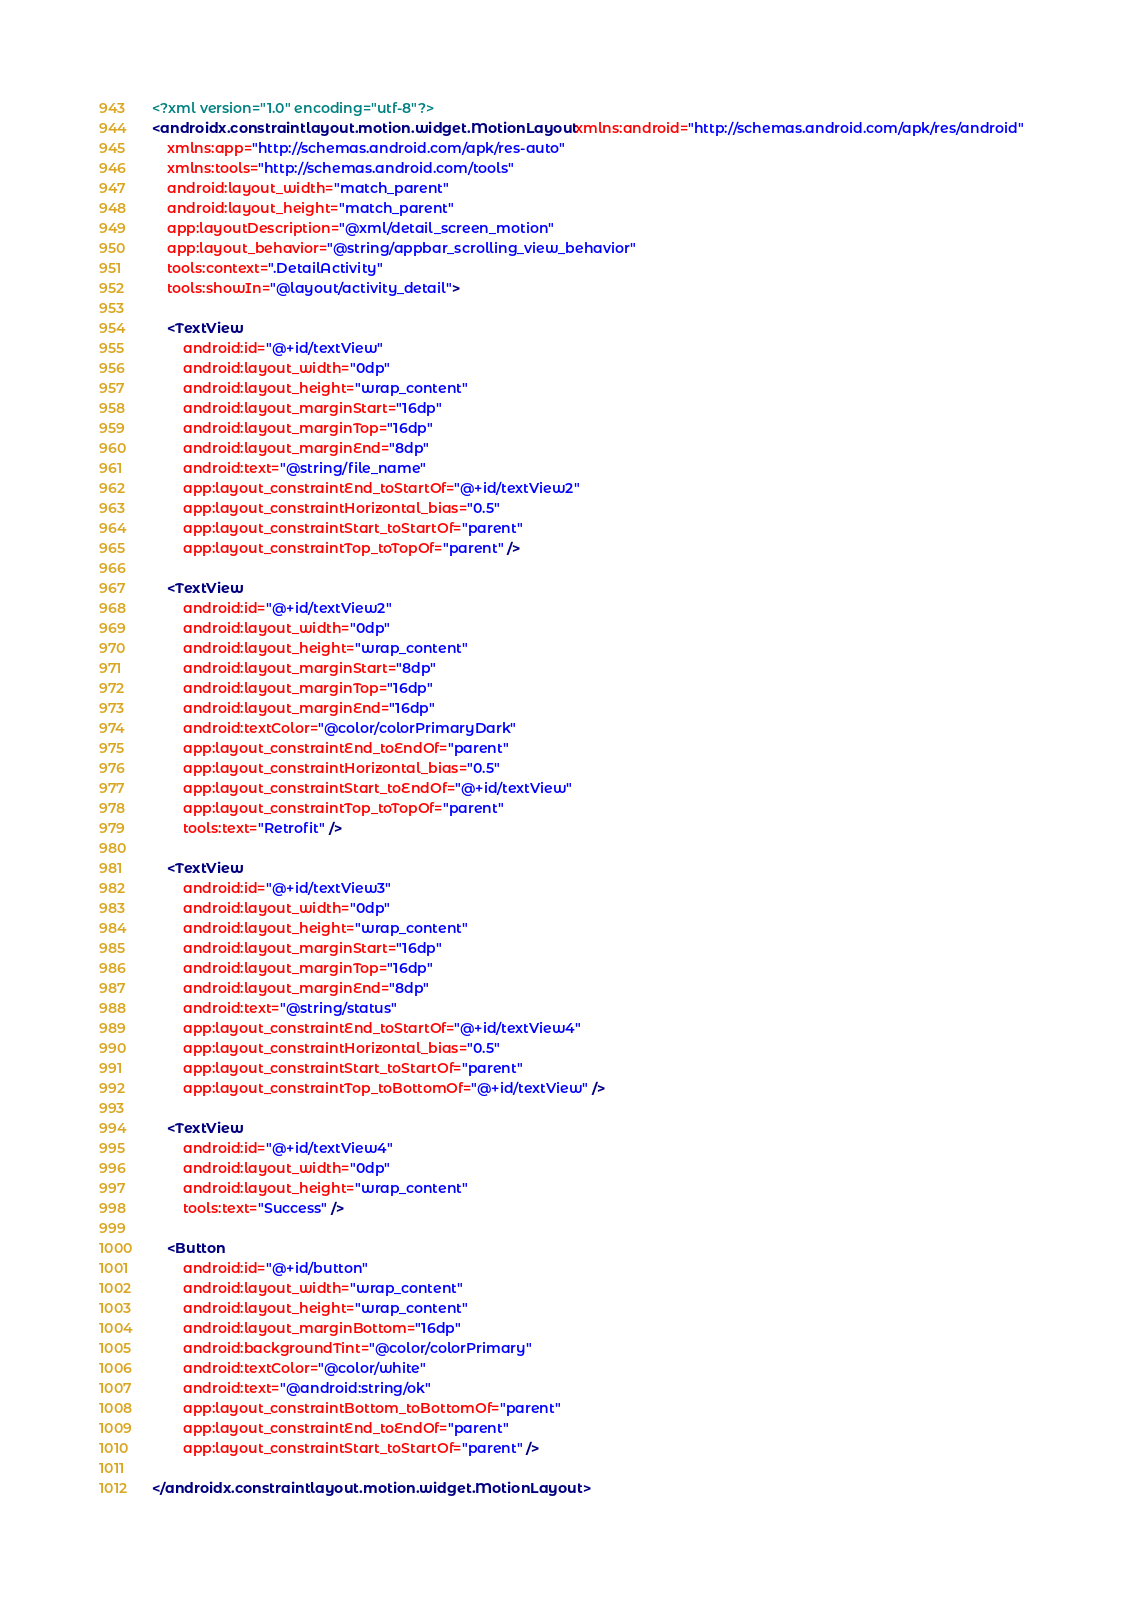<code> <loc_0><loc_0><loc_500><loc_500><_XML_><?xml version="1.0" encoding="utf-8"?>
<androidx.constraintlayout.motion.widget.MotionLayout xmlns:android="http://schemas.android.com/apk/res/android"
    xmlns:app="http://schemas.android.com/apk/res-auto"
    xmlns:tools="http://schemas.android.com/tools"
    android:layout_width="match_parent"
    android:layout_height="match_parent"
    app:layoutDescription="@xml/detail_screen_motion"
    app:layout_behavior="@string/appbar_scrolling_view_behavior"
    tools:context=".DetailActivity"
    tools:showIn="@layout/activity_detail">

    <TextView
        android:id="@+id/textView"
        android:layout_width="0dp"
        android:layout_height="wrap_content"
        android:layout_marginStart="16dp"
        android:layout_marginTop="16dp"
        android:layout_marginEnd="8dp"
        android:text="@string/file_name"
        app:layout_constraintEnd_toStartOf="@+id/textView2"
        app:layout_constraintHorizontal_bias="0.5"
        app:layout_constraintStart_toStartOf="parent"
        app:layout_constraintTop_toTopOf="parent" />

    <TextView
        android:id="@+id/textView2"
        android:layout_width="0dp"
        android:layout_height="wrap_content"
        android:layout_marginStart="8dp"
        android:layout_marginTop="16dp"
        android:layout_marginEnd="16dp"
        android:textColor="@color/colorPrimaryDark"
        app:layout_constraintEnd_toEndOf="parent"
        app:layout_constraintHorizontal_bias="0.5"
        app:layout_constraintStart_toEndOf="@+id/textView"
        app:layout_constraintTop_toTopOf="parent"
        tools:text="Retrofit" />

    <TextView
        android:id="@+id/textView3"
        android:layout_width="0dp"
        android:layout_height="wrap_content"
        android:layout_marginStart="16dp"
        android:layout_marginTop="16dp"
        android:layout_marginEnd="8dp"
        android:text="@string/status"
        app:layout_constraintEnd_toStartOf="@+id/textView4"
        app:layout_constraintHorizontal_bias="0.5"
        app:layout_constraintStart_toStartOf="parent"
        app:layout_constraintTop_toBottomOf="@+id/textView" />

    <TextView
        android:id="@+id/textView4"
        android:layout_width="0dp"
        android:layout_height="wrap_content"
        tools:text="Success" />

    <Button
        android:id="@+id/button"
        android:layout_width="wrap_content"
        android:layout_height="wrap_content"
        android:layout_marginBottom="16dp"
        android:backgroundTint="@color/colorPrimary"
        android:textColor="@color/white"
        android:text="@android:string/ok"
        app:layout_constraintBottom_toBottomOf="parent"
        app:layout_constraintEnd_toEndOf="parent"
        app:layout_constraintStart_toStartOf="parent" />

</androidx.constraintlayout.motion.widget.MotionLayout></code> 